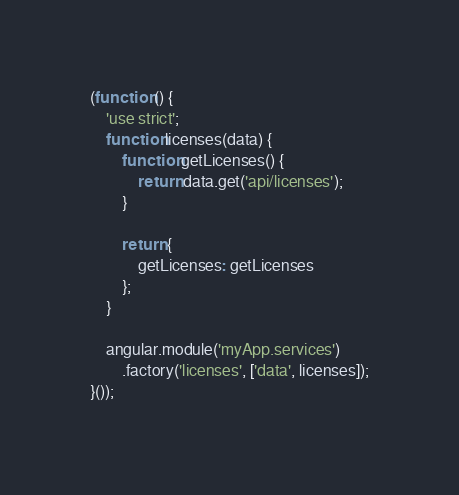<code> <loc_0><loc_0><loc_500><loc_500><_JavaScript_>(function () {
    'use strict';
    function licenses(data) {
        function getLicenses() {
            return data.get('api/licenses');
        }

        return {
            getLicenses: getLicenses
        };
    }

    angular.module('myApp.services')
        .factory('licenses', ['data', licenses]);
}());
</code> 